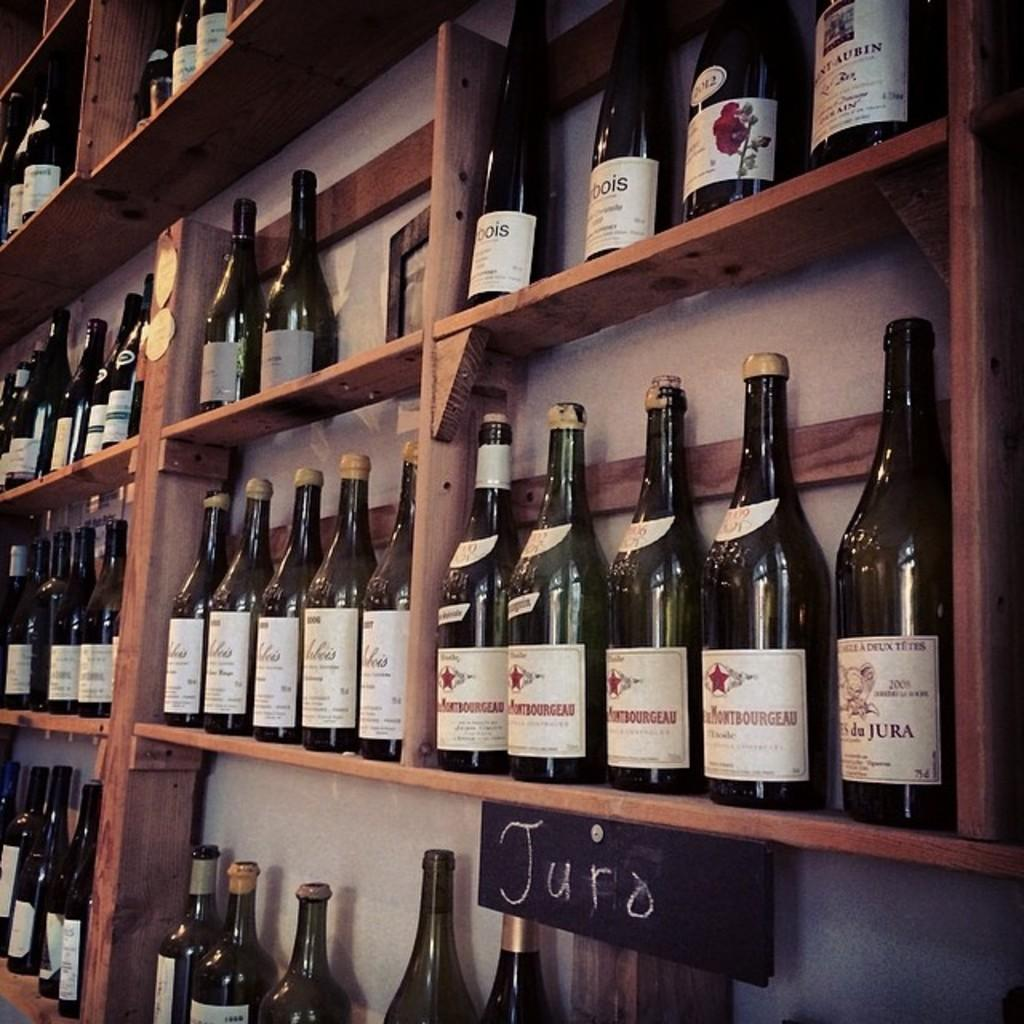<image>
Write a terse but informative summary of the picture. A variety of wine bottles are arranged on a wall on wooden shelves with the label Juro on the bottom on the right. 